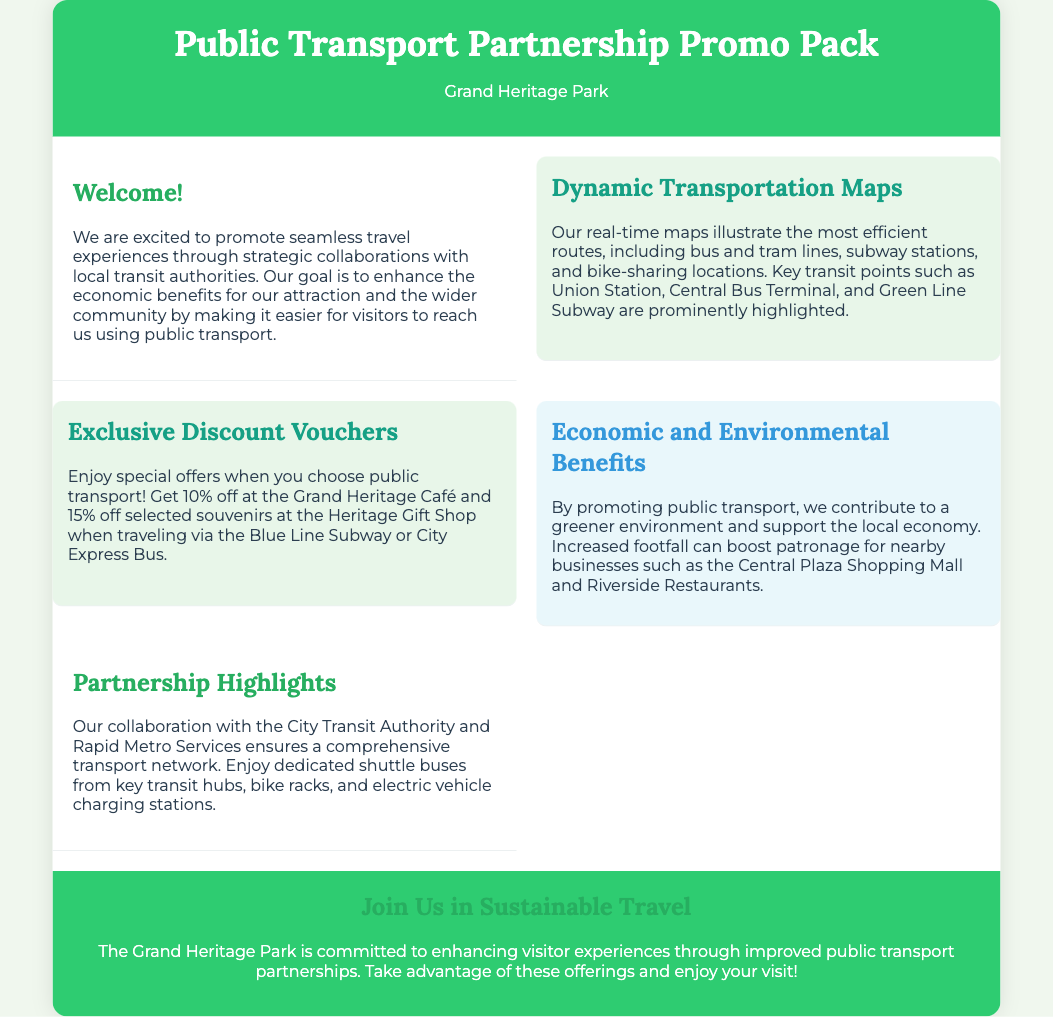What is the name of the tourist attraction? The document states that the tourist attraction is called "Grand Heritage Park."
Answer: Grand Heritage Park What discount is offered at the Grand Heritage Café? The document specifies a discount of 10% at the Grand Heritage Café.
Answer: 10% Which transit authority does the park collaborate with? The collaboration is mentioned with the "City Transit Authority."
Answer: City Transit Authority What is highlighted in the dynamic transportation maps? The maps illustrate "efficient routes, including bus and tram lines."
Answer: Efficient routes What is the economic benefit of promoting public transport? The document indicates that promoting public transport supports "the local economy."
Answer: Local economy How much discount is available at the Heritage Gift Shop? The document mentions a discount of 15% at the Heritage Gift Shop.
Answer: 15% What type of services are mentioned as part of the partnership highlights? The document discusses "dedicated shuttle buses from key transit hubs."
Answer: Dedicated shuttle buses What is the background color of the header section? The document describes the header section's background color as "#2ecc71."
Answer: #2ecc71 What is the main commitment of Grand Heritage Park? The document states the commitment is to "enhancing visitor experiences."
Answer: Enhancing visitor experiences 